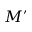<formula> <loc_0><loc_0><loc_500><loc_500>M ^ { \prime }</formula> 